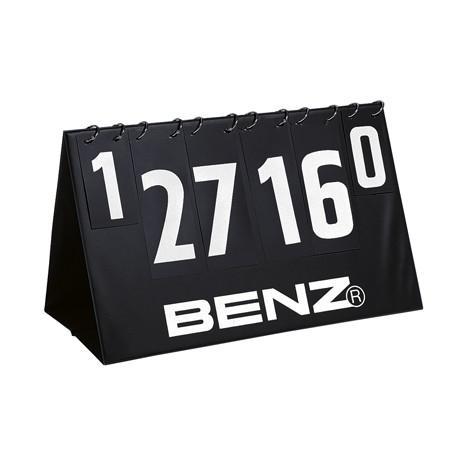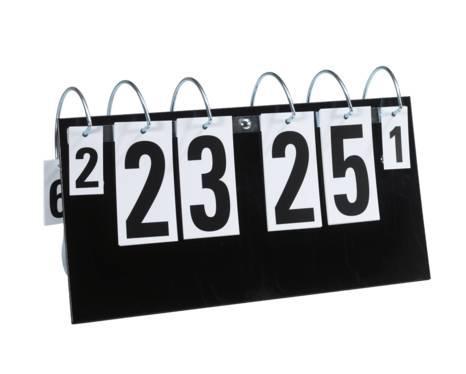The first image is the image on the left, the second image is the image on the right. Given the left and right images, does the statement "In at least one image there is a total of four zeros." hold true? Answer yes or no. No. The first image is the image on the left, the second image is the image on the right. For the images displayed, is the sentence "There are eight rings in the left image." factually correct? Answer yes or no. No. 